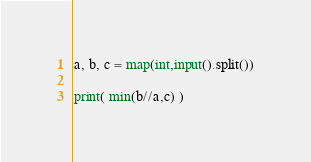<code> <loc_0><loc_0><loc_500><loc_500><_Python_>
a, b, c = map(int,input().split())

print( min(b//a,c) ) 
</code> 